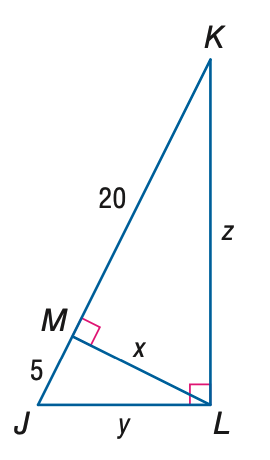Question: Find x.
Choices:
A. 5
B. 10
C. 20
D. 100
Answer with the letter. Answer: B Question: Find z.
Choices:
A. 10
B. 10 \sqrt { 3 }
C. 20
D. 10 \sqrt { 5 }
Answer with the letter. Answer: D 